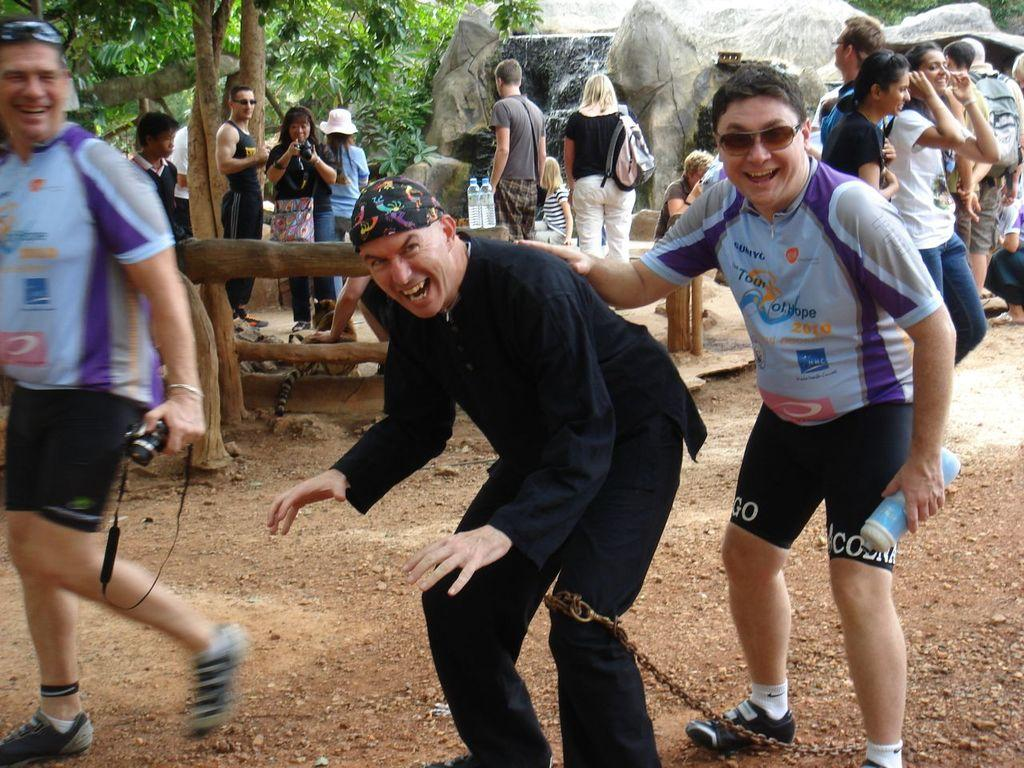What are the people in the image doing? There are people standing and walking in the image. What type of natural elements can be seen in the image? There are rocks and trees visible in the image. How many water bottles are present in the image? There are two water bottles in the image. What type of company is represented by the scale in the image? There is no scale present in the image, so it is not possible to determine the type of company represented. 